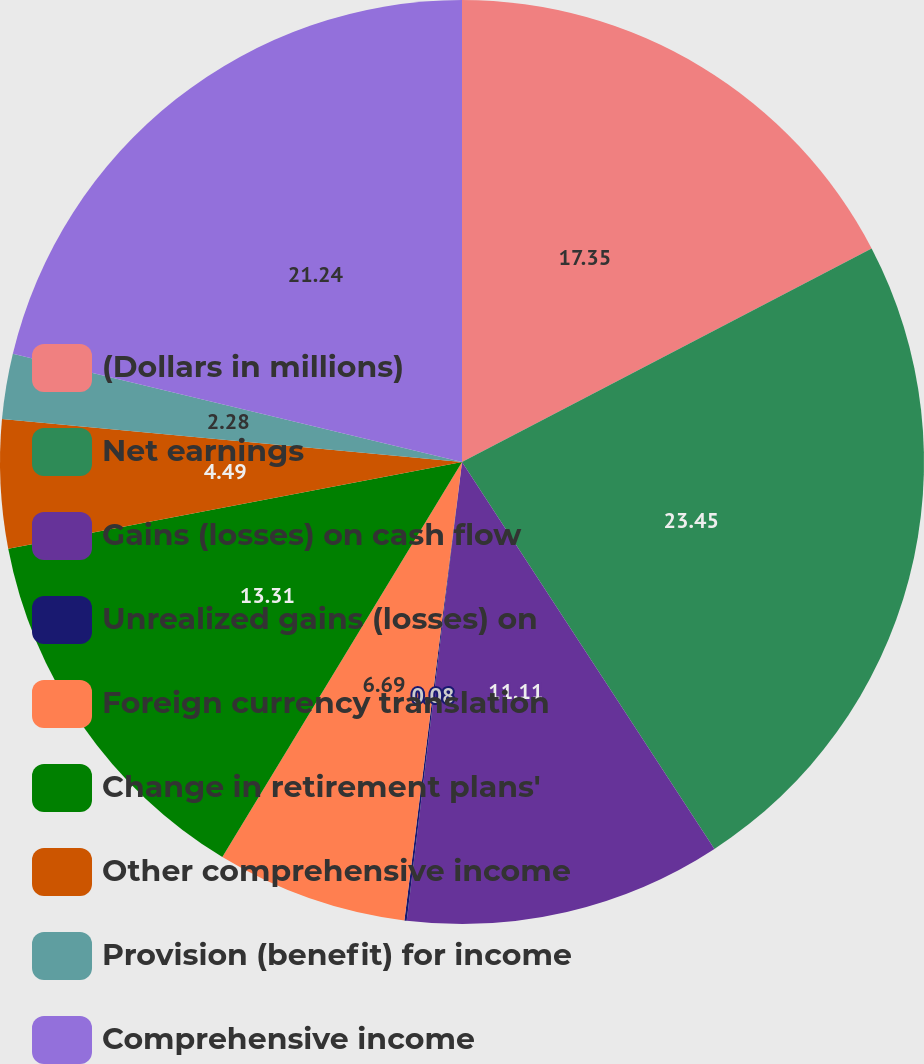Convert chart to OTSL. <chart><loc_0><loc_0><loc_500><loc_500><pie_chart><fcel>(Dollars in millions)<fcel>Net earnings<fcel>Gains (losses) on cash flow<fcel>Unrealized gains (losses) on<fcel>Foreign currency translation<fcel>Change in retirement plans'<fcel>Other comprehensive income<fcel>Provision (benefit) for income<fcel>Comprehensive income<nl><fcel>17.35%<fcel>23.45%<fcel>11.11%<fcel>0.08%<fcel>6.69%<fcel>13.31%<fcel>4.49%<fcel>2.28%<fcel>21.24%<nl></chart> 